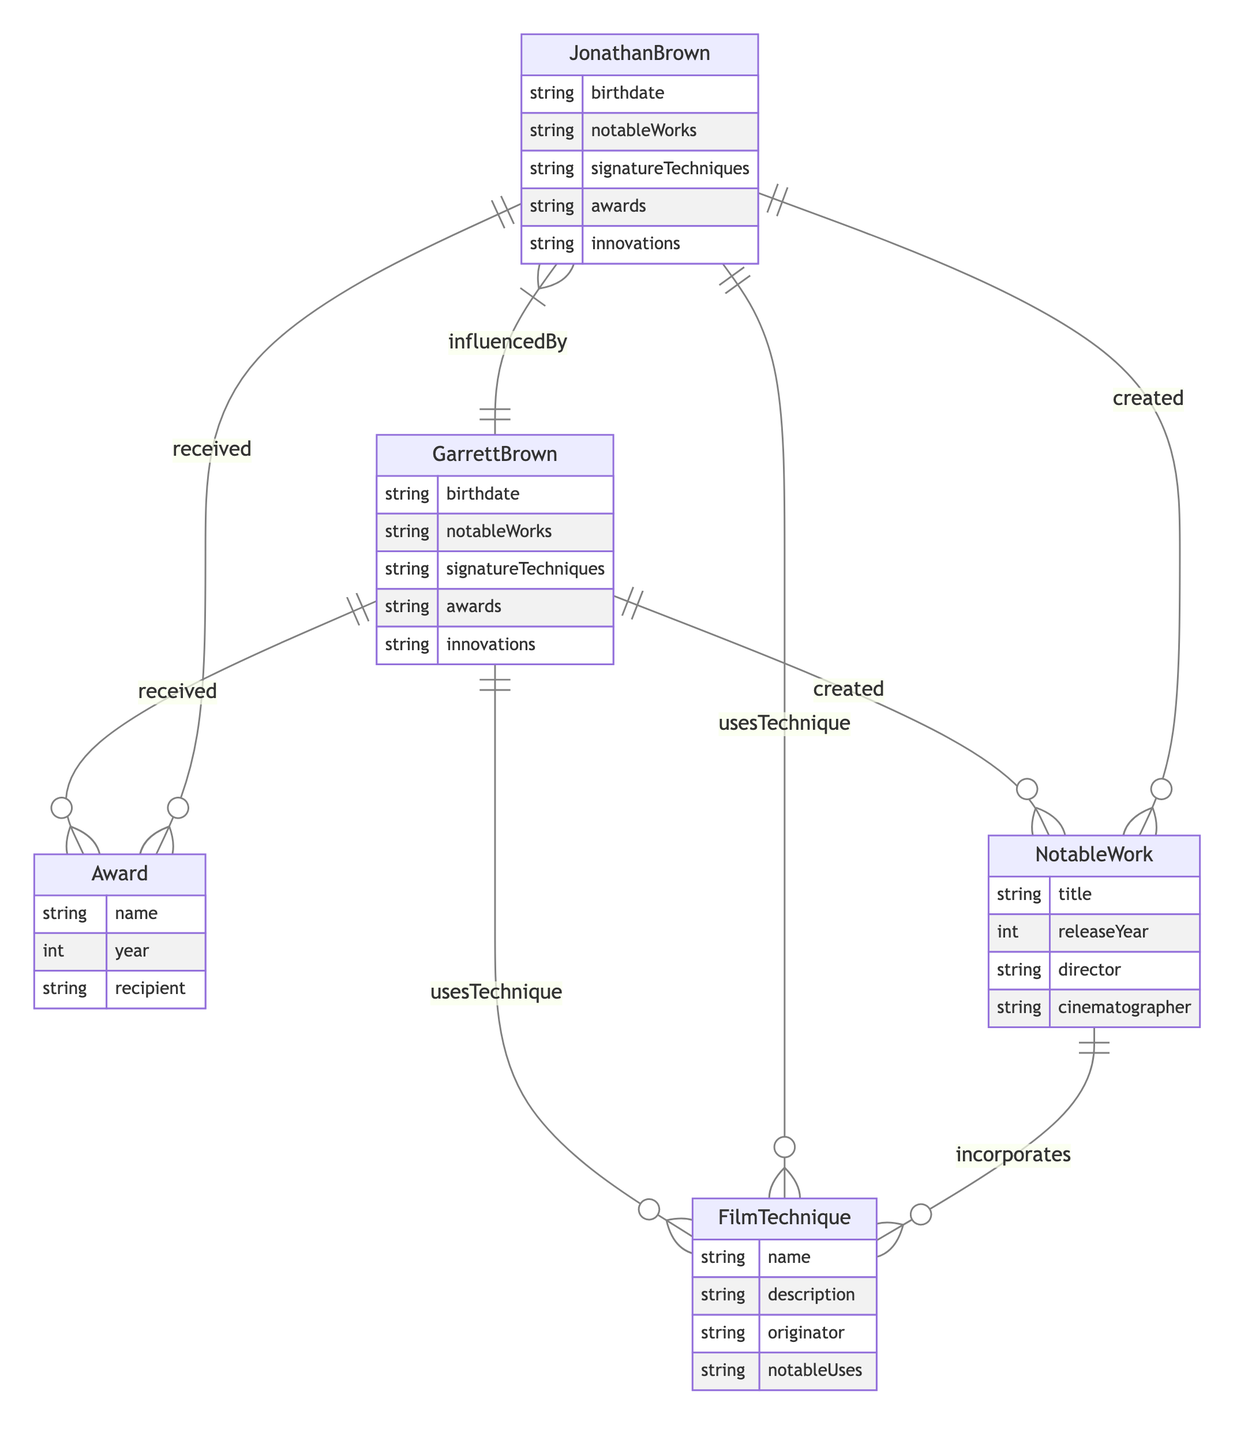What is the birthdate of Garrett Brown? The diagram indicates Garrett Brown's attributes, one of which is "birthdate." By directly referencing this attribute, we can identify the information we need.
Answer: birthdate How many awards has Jonathan Brown received? The diagram relates Jonathan Brown to the Award entity through the "received" relationship. By counting the instances connected to Jonathan Brown, we can determine the number of awards.
Answer: number of awards What is the name of a film technique used by Garrett Brown? The "usesTechnique" relationship links Garrett Brown to the FilmTechnique entity. By tracing this relationship, we can find at least one technique associated with him.
Answer: name of a film technique Which notable work did Garrett Brown create? The "created" relationship connects Garrett Brown to NotableWork. By looking at this relationship, we can find one of the notable works he originated.
Answer: title of a notable work Who has influenced Jonathan Brown? According to the "influencedBy" relationship, Jonathan Brown is influenced by Garrett Brown. This is a direct path in the diagram that allows us to identify his influence.
Answer: Garrett Brown How many notable works does Jonathan Brown have? The "created" relationship allows us to connect Jonathan Brown to the NotableWork entity. Counting the instances associated with Jonathan Brown provides the total number of his notable works.
Answer: number of notable works What is a signature technique of Jonathan Brown? Following the "usesTechnique" relationship, we can trace Jonathan Brown's connection to FilmTechnique, which reveals his signature techniques. By reviewing these links, we can extract one of his techniques.
Answer: signature technique In what year did Garrett Brown receive his first award? By analyzing the "received" relationship for Garrett Brown, we can look at the Award entity and identify the year associated with his first recorded award from the list.
Answer: year of first award What technique was incorporated in Jonathan Brown's notable works? The diagram allows us to see the "incorporates" relationship connecting NotableWork with FilmTechnique. By checking Jonathan Brown's notable works, we can identify one technique that was integrated into them.
Answer: name of incorporated technique 